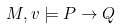<formula> <loc_0><loc_0><loc_500><loc_500>M , v \models P \rightarrow Q</formula> 